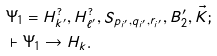Convert formula to latex. <formula><loc_0><loc_0><loc_500><loc_500>& \Psi _ { 1 } = H _ { k ^ { \prime } } ^ { ? } , H _ { \ell ^ { \prime } } ^ { ? } , S _ { p _ { i ^ { \prime } } , q _ { i ^ { \prime } } , r _ { i ^ { \prime } } } , B ^ { \prime } _ { 2 } , \vec { K } ; \\ & \vdash \Psi _ { 1 } \to H _ { k } .</formula> 